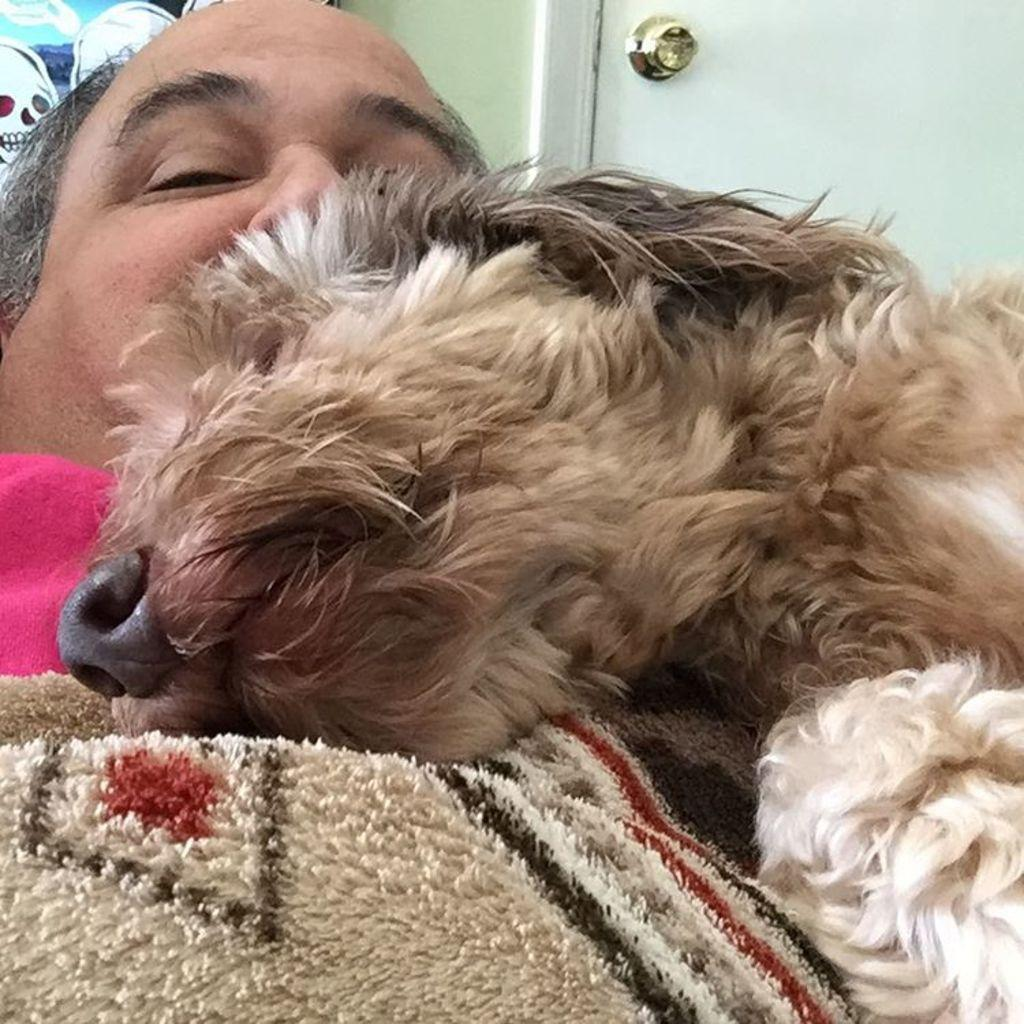Who is present in the image? There is a man in the image. What other living creature can be seen in the image? There is a dog in the image. What architectural feature is visible in the background of the image? There is a door visible in the background of the image. What type of advertisement can be seen on the bed in the image? There is no bed or advertisement present in the image. 